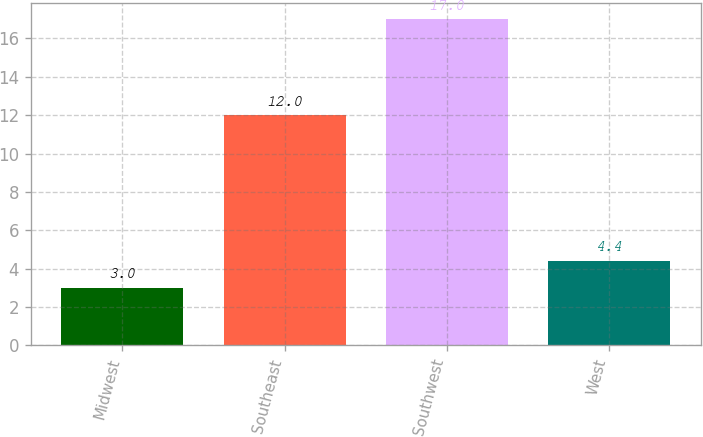Convert chart. <chart><loc_0><loc_0><loc_500><loc_500><bar_chart><fcel>Midwest<fcel>Southeast<fcel>Southwest<fcel>West<nl><fcel>3<fcel>12<fcel>17<fcel>4.4<nl></chart> 